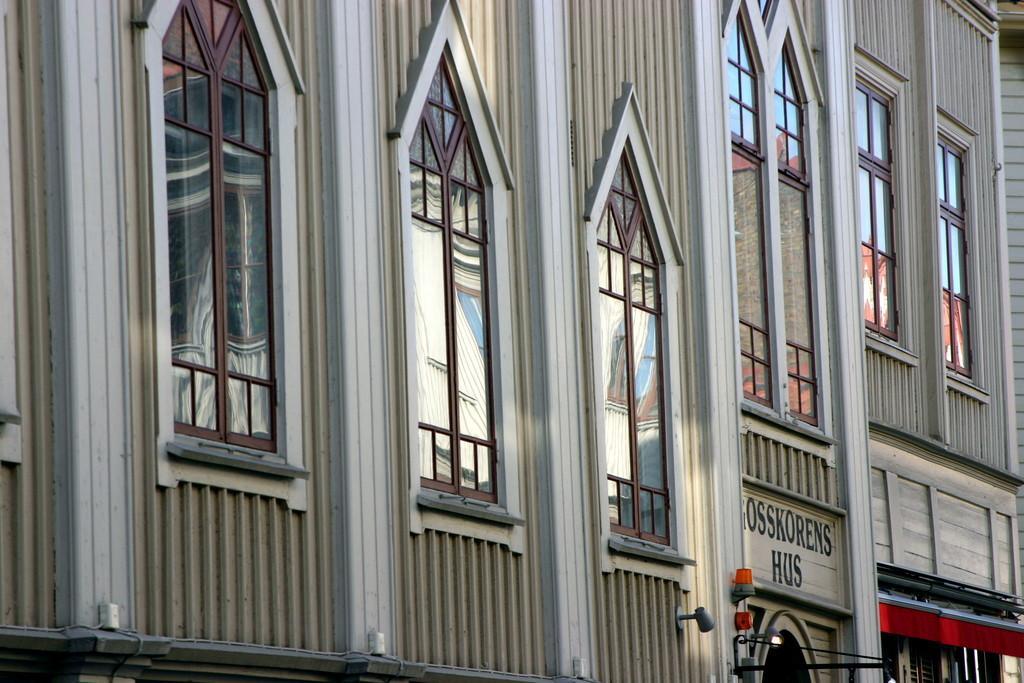Can you describe this image briefly? In this image there is a building. 